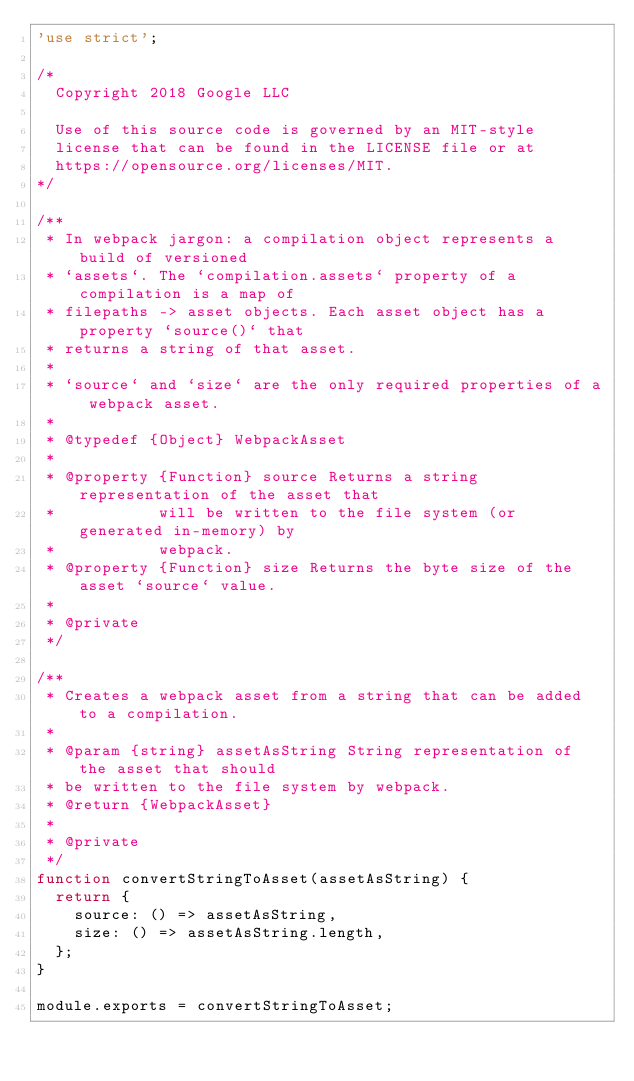Convert code to text. <code><loc_0><loc_0><loc_500><loc_500><_JavaScript_>'use strict';

/*
  Copyright 2018 Google LLC

  Use of this source code is governed by an MIT-style
  license that can be found in the LICENSE file or at
  https://opensource.org/licenses/MIT.
*/

/**
 * In webpack jargon: a compilation object represents a build of versioned
 * `assets`. The `compilation.assets` property of a compilation is a map of
 * filepaths -> asset objects. Each asset object has a property `source()` that
 * returns a string of that asset.
 *
 * `source` and `size` are the only required properties of a webpack asset.
 *
 * @typedef {Object} WebpackAsset
 *
 * @property {Function} source Returns a string representation of the asset that
 *           will be written to the file system (or generated in-memory) by
 *           webpack.
 * @property {Function} size Returns the byte size of the asset `source` value.
 *
 * @private
 */

/**
 * Creates a webpack asset from a string that can be added to a compilation.
 *
 * @param {string} assetAsString String representation of the asset that should
 * be written to the file system by webpack.
 * @return {WebpackAsset}
 *
 * @private
 */
function convertStringToAsset(assetAsString) {
  return {
    source: () => assetAsString,
    size: () => assetAsString.length,
  };
}

module.exports = convertStringToAsset;
</code> 